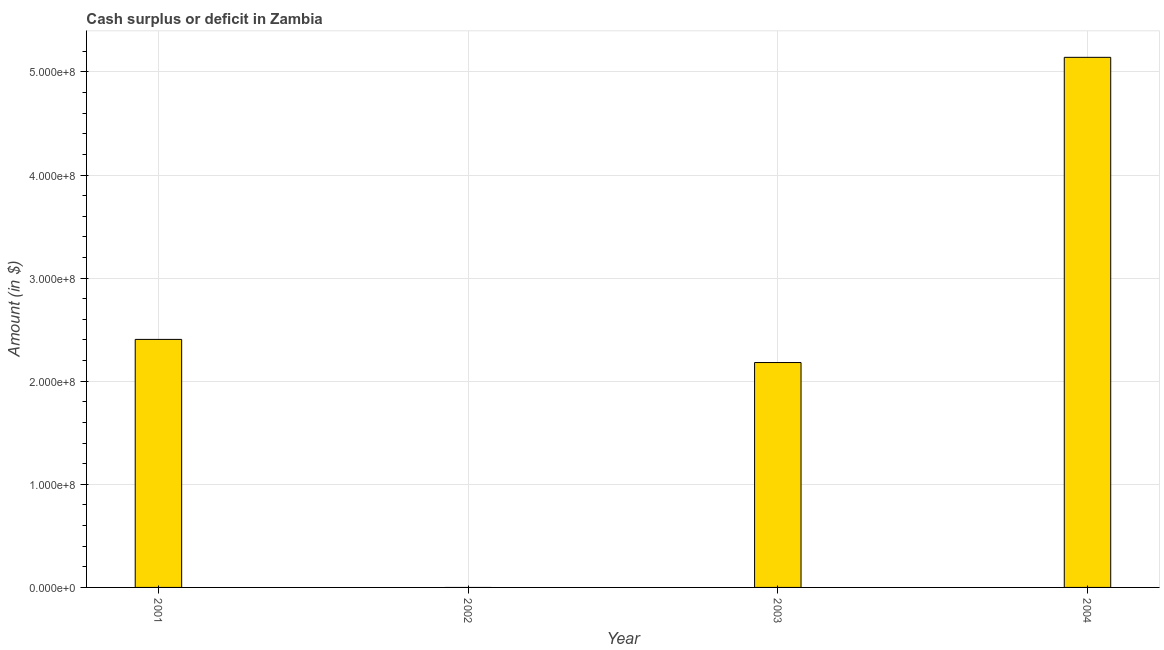Does the graph contain grids?
Ensure brevity in your answer.  Yes. What is the title of the graph?
Keep it short and to the point. Cash surplus or deficit in Zambia. What is the label or title of the Y-axis?
Keep it short and to the point. Amount (in $). What is the cash surplus or deficit in 2001?
Keep it short and to the point. 2.41e+08. Across all years, what is the maximum cash surplus or deficit?
Provide a succinct answer. 5.14e+08. Across all years, what is the minimum cash surplus or deficit?
Ensure brevity in your answer.  0. In which year was the cash surplus or deficit maximum?
Give a very brief answer. 2004. What is the sum of the cash surplus or deficit?
Your response must be concise. 9.73e+08. What is the difference between the cash surplus or deficit in 2001 and 2003?
Your response must be concise. 2.24e+07. What is the average cash surplus or deficit per year?
Make the answer very short. 2.43e+08. What is the median cash surplus or deficit?
Your answer should be compact. 2.29e+08. In how many years, is the cash surplus or deficit greater than 340000000 $?
Your response must be concise. 1. What is the ratio of the cash surplus or deficit in 2001 to that in 2004?
Offer a very short reply. 0.47. Is the cash surplus or deficit in 2001 less than that in 2003?
Keep it short and to the point. No. Is the difference between the cash surplus or deficit in 2001 and 2003 greater than the difference between any two years?
Your answer should be very brief. No. What is the difference between the highest and the second highest cash surplus or deficit?
Keep it short and to the point. 2.74e+08. Is the sum of the cash surplus or deficit in 2003 and 2004 greater than the maximum cash surplus or deficit across all years?
Offer a terse response. Yes. What is the difference between the highest and the lowest cash surplus or deficit?
Ensure brevity in your answer.  5.14e+08. How many bars are there?
Keep it short and to the point. 3. How many years are there in the graph?
Keep it short and to the point. 4. What is the difference between two consecutive major ticks on the Y-axis?
Make the answer very short. 1.00e+08. Are the values on the major ticks of Y-axis written in scientific E-notation?
Provide a short and direct response. Yes. What is the Amount (in $) in 2001?
Your answer should be compact. 2.41e+08. What is the Amount (in $) in 2003?
Your response must be concise. 2.18e+08. What is the Amount (in $) in 2004?
Keep it short and to the point. 5.14e+08. What is the difference between the Amount (in $) in 2001 and 2003?
Your answer should be compact. 2.24e+07. What is the difference between the Amount (in $) in 2001 and 2004?
Offer a terse response. -2.74e+08. What is the difference between the Amount (in $) in 2003 and 2004?
Provide a succinct answer. -2.96e+08. What is the ratio of the Amount (in $) in 2001 to that in 2003?
Keep it short and to the point. 1.1. What is the ratio of the Amount (in $) in 2001 to that in 2004?
Your answer should be compact. 0.47. What is the ratio of the Amount (in $) in 2003 to that in 2004?
Make the answer very short. 0.42. 